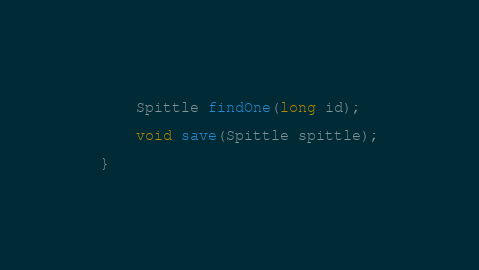Convert code to text. <code><loc_0><loc_0><loc_500><loc_500><_Java_>    Spittle findOne(long id);

    void save(Spittle spittle);

}
</code> 